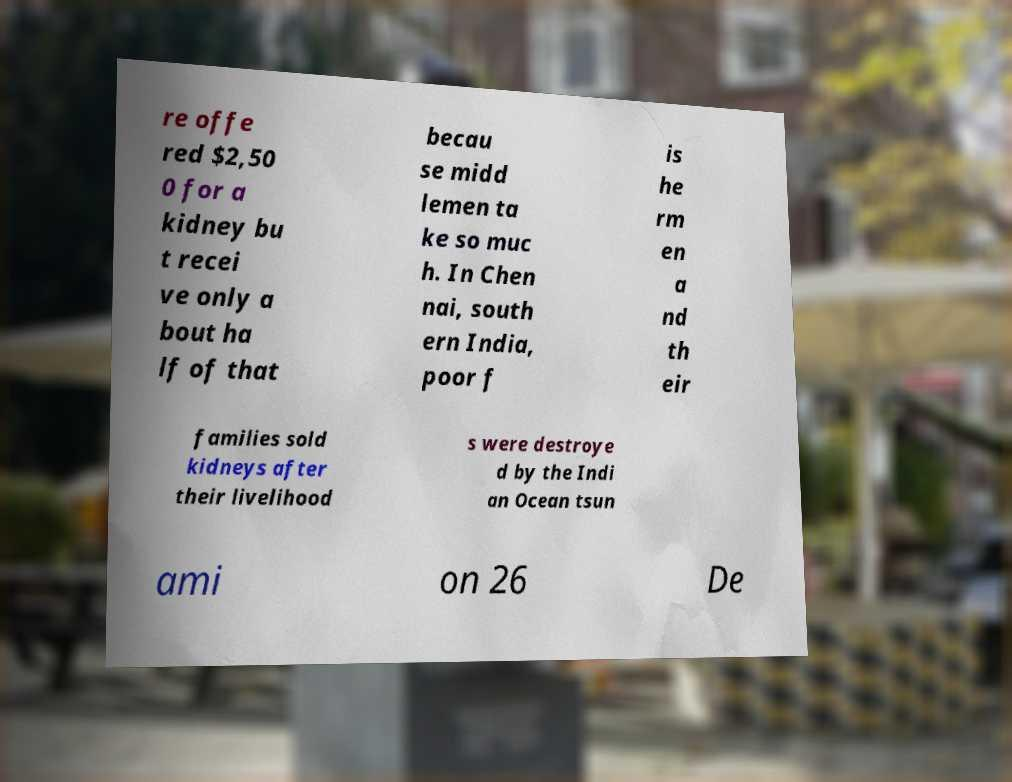Can you read and provide the text displayed in the image?This photo seems to have some interesting text. Can you extract and type it out for me? re offe red $2,50 0 for a kidney bu t recei ve only a bout ha lf of that becau se midd lemen ta ke so muc h. In Chen nai, south ern India, poor f is he rm en a nd th eir families sold kidneys after their livelihood s were destroye d by the Indi an Ocean tsun ami on 26 De 